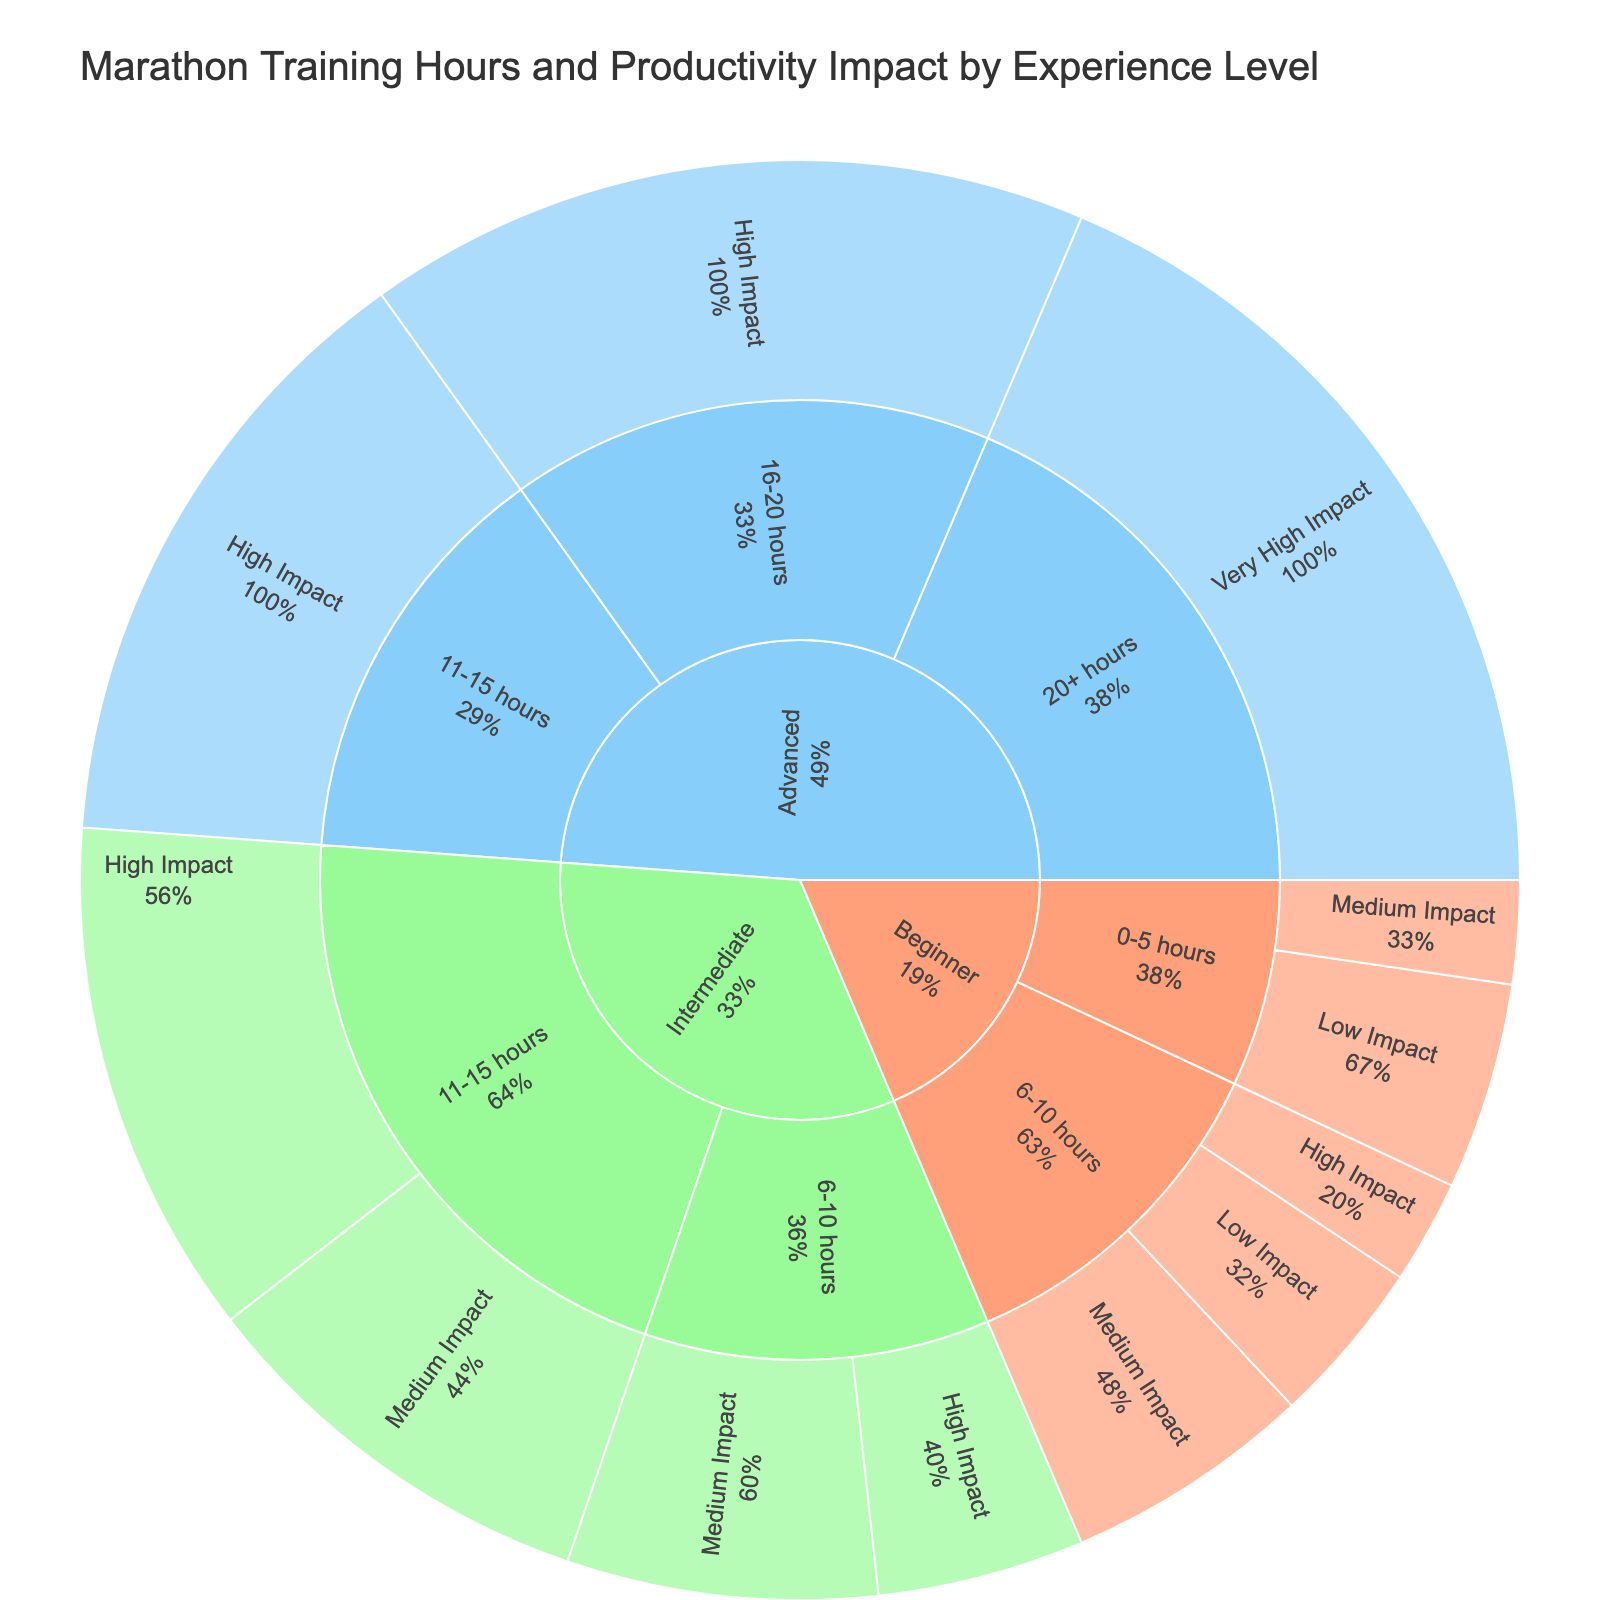What is the title of the figure? The title of the figure is located at the top, typically in larger and bold font, to provide a description of what the figure represents. In this case, it states "Marathon Training Hours and Productivity Impact by Experience Level"
Answer: Marathon Training Hours and Productivity Impact by Experience Level How many productivity impact categories are represented for beginners? Within the sunburst plot, follow the path under 'Beginner' and count the distinct segments for productivity impact categories. Here, there are three: Low Impact, Medium Impact, and High Impact
Answer: Three What color represents the Intermediate experience level? Colors in the sunburst plot use the given color scheme. According to the specified color map, Intermediate is represented by green
Answer: Green Which experience level has the highest value in a single segment, and what is that value? Check each segment in the sunburst plot and identify the one with the highest value. The Advanced level with '20+ hours' and 'Very High Impact' has a value of 40
Answer: Advanced, 40 What is the combined value for Intermediate experience levels with 'Medium Impact'? Combine the values from segments under Intermediate experience level with 'Medium Impact'. These are 15 for 6-10 hours and 20 for 11-15 hours, totaling to 35
Answer: 35 Compare the value of High Impact between Intermediate and Advanced experience levels. Which is greater and by how much? From the sunburst plot, locate the High Impact values for Intermediate (10 for 6-10 hours and 25 for 11-15 hours) and Advanced (30 for 11-15 hours and 35 for 16-20 hours). The sum for Intermediate is 10 + 25 = 35, and for Advanced is 30 + 35 = 65. The difference is 65 - 35 = 30
Answer: Advanced, by 30 What proportion of the total value for Advanced experience level is contributed by '16-20 hours'? Calculate the total value for the Advanced experience level by summing all segments. Then find the proportion contributed by '16-20 hours' which is 35 out of (30 + 35 + 40) = 105. Thus, the proportion is 35/105
Answer: 1/3 Which productive impact category is not present for the Advanced experience level? Examine all segments under the Advanced category and identify any missing productivity impact. 'Low Impact' and 'Medium Impact' are not present for Advanced
Answer: Low Impact, Medium Impact How does the productivity impact change with increasing training hours for Advanced experience level? Analyze the trend for the Advanced category. As training hours increase (from 11-15 hours to 20+ hours), the productivity impact shifts from 'High Impact' to 'Very High Impact'
Answer: Increases 